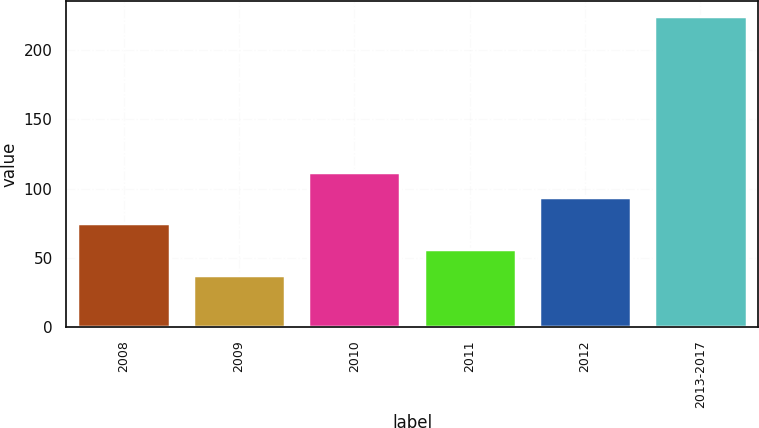Convert chart. <chart><loc_0><loc_0><loc_500><loc_500><bar_chart><fcel>2008<fcel>2009<fcel>2010<fcel>2011<fcel>2012<fcel>2013-2017<nl><fcel>74.92<fcel>37.5<fcel>112.34<fcel>56.21<fcel>93.63<fcel>224.6<nl></chart> 